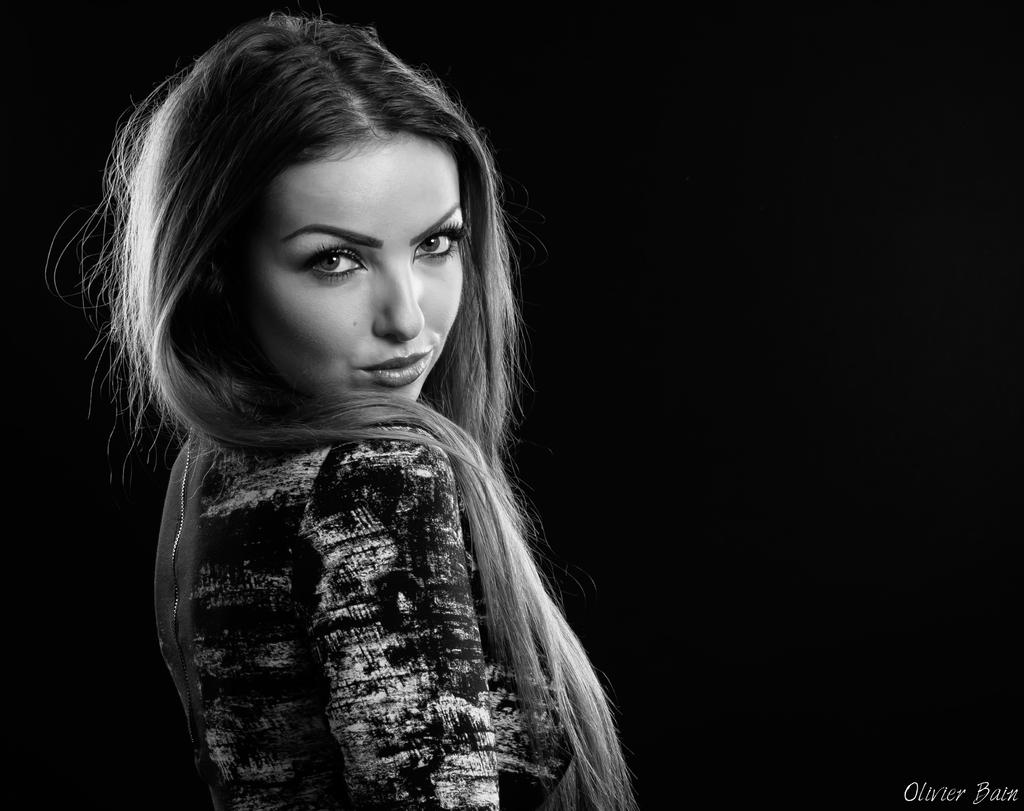What is the color scheme of the image? The image is black and white. Who or what is the main subject in the image? There is a woman in the image. How would you describe the background of the image? The background of the image is dark. Is there any additional information or marking in the image? Yes, there is a watermark in the bottom right corner of the image. Can you see any fairies flying around the woman in the image? No, there are no fairies present in the image. What type of glass object is the woman holding in the image? There is no glass object visible in the image. 